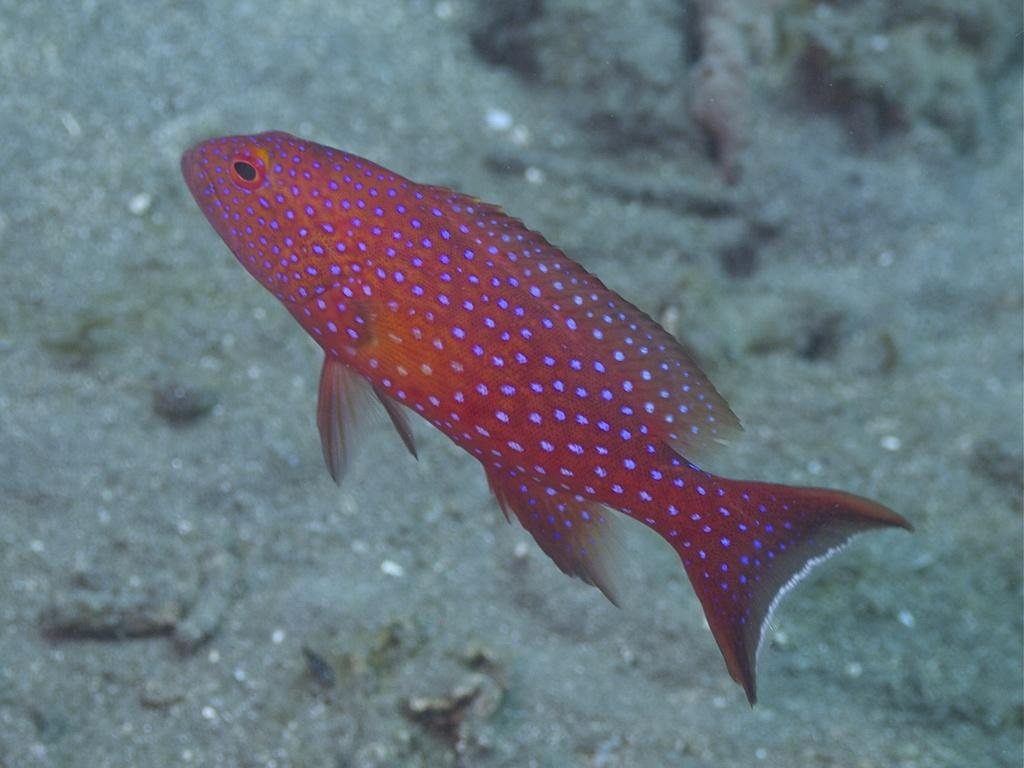What type of animal is in the image? There is a fish in the image. What can be seen in the background of the image? The background of the image contains sand. Where is the desk located in the image? There is no desk present in the image. What type of sweater is the fish wearing in the image? Fish do not wear sweaters, and there is no sweater present in the image. 